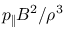<formula> <loc_0><loc_0><loc_500><loc_500>p _ { \| } B ^ { 2 } / \rho ^ { 3 }</formula> 